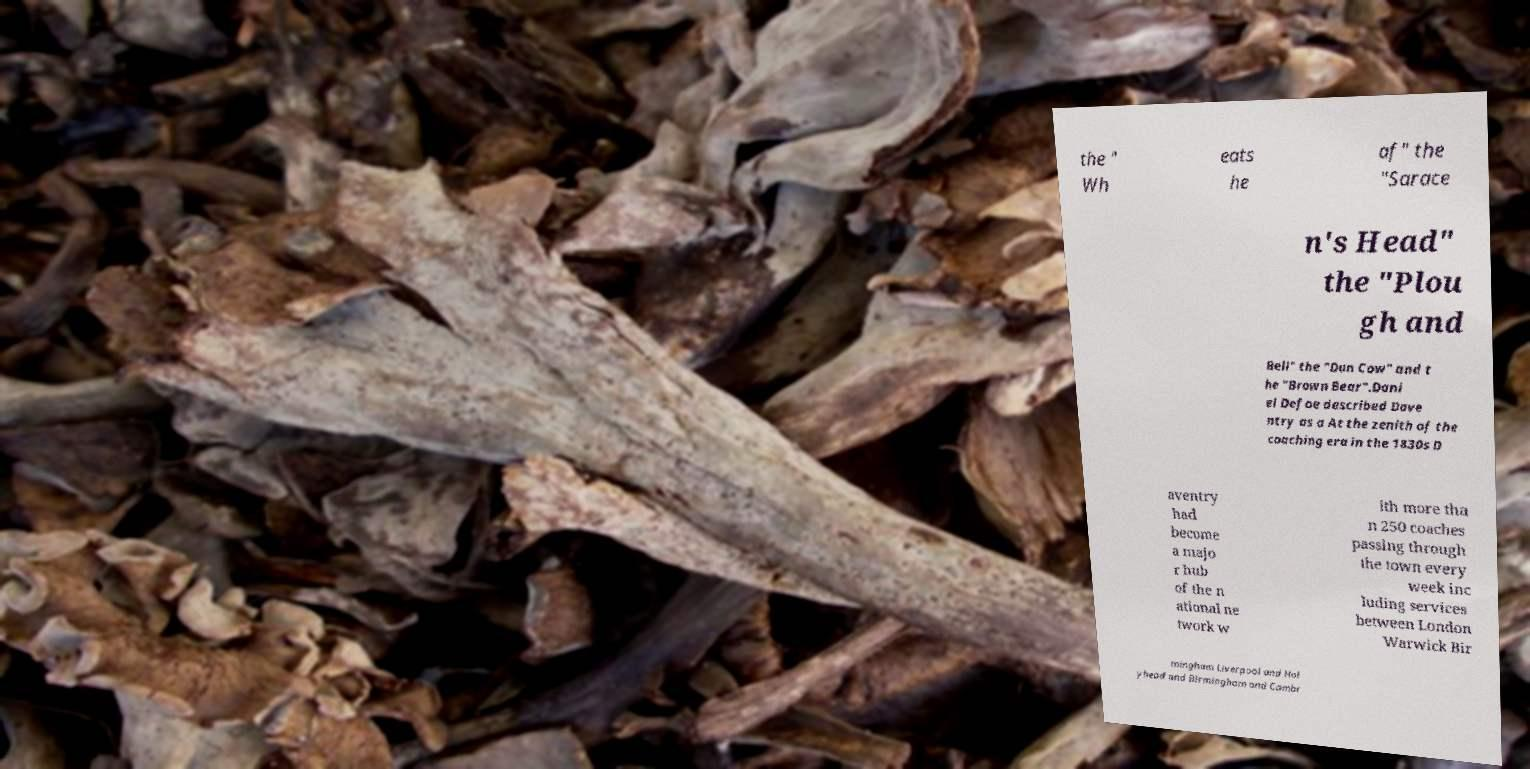I need the written content from this picture converted into text. Can you do that? the " Wh eats he af" the "Sarace n's Head" the "Plou gh and Bell" the "Dun Cow" and t he "Brown Bear".Dani el Defoe described Dave ntry as a At the zenith of the coaching era in the 1830s D aventry had become a majo r hub of the n ational ne twork w ith more tha n 250 coaches passing through the town every week inc luding services between London Warwick Bir mingham Liverpool and Hol yhead and Birmingham and Cambr 